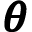<formula> <loc_0><loc_0><loc_500><loc_500>\pm b \theta</formula> 